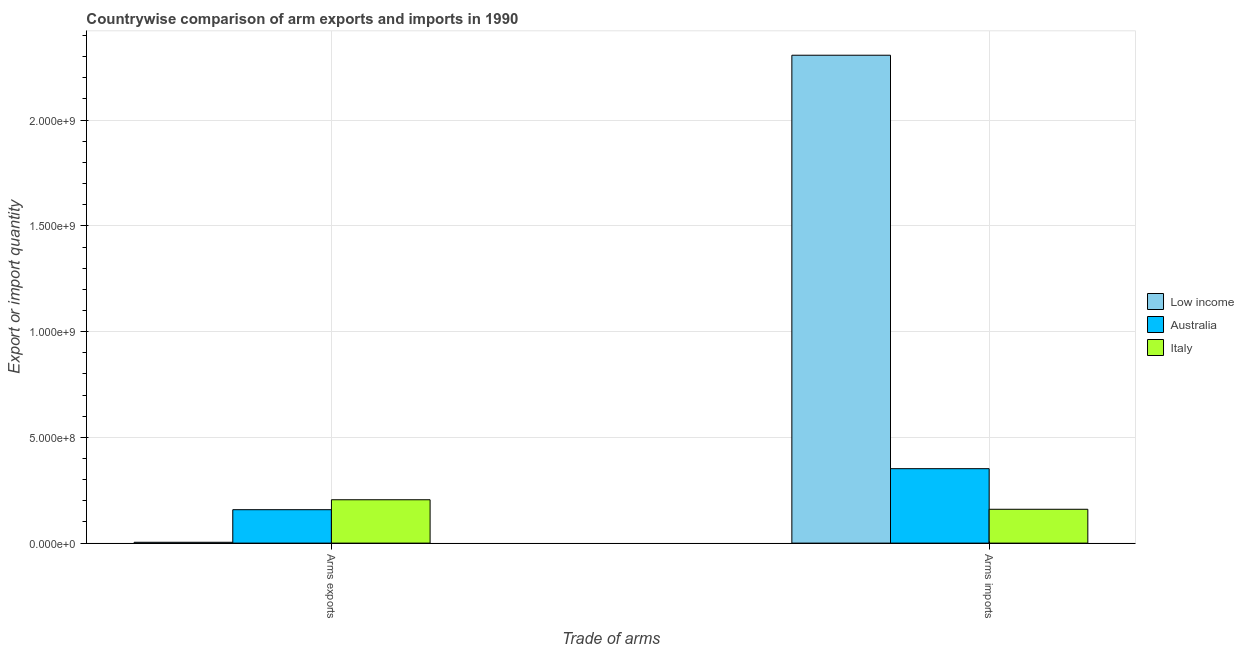How many different coloured bars are there?
Keep it short and to the point. 3. How many groups of bars are there?
Ensure brevity in your answer.  2. Are the number of bars per tick equal to the number of legend labels?
Make the answer very short. Yes. How many bars are there on the 2nd tick from the left?
Your answer should be compact. 3. What is the label of the 1st group of bars from the left?
Your answer should be very brief. Arms exports. What is the arms imports in Australia?
Give a very brief answer. 3.52e+08. Across all countries, what is the maximum arms imports?
Offer a very short reply. 2.31e+09. Across all countries, what is the minimum arms imports?
Offer a terse response. 1.60e+08. In which country was the arms exports maximum?
Provide a succinct answer. Italy. What is the total arms exports in the graph?
Provide a short and direct response. 3.67e+08. What is the difference between the arms exports in Australia and that in Low income?
Ensure brevity in your answer.  1.54e+08. What is the difference between the arms exports in Italy and the arms imports in Low income?
Ensure brevity in your answer.  -2.10e+09. What is the average arms exports per country?
Give a very brief answer. 1.22e+08. What is the difference between the arms imports and arms exports in Australia?
Ensure brevity in your answer.  1.94e+08. In how many countries, is the arms exports greater than 200000000 ?
Keep it short and to the point. 1. What is the ratio of the arms exports in Low income to that in Italy?
Your answer should be compact. 0.02. What does the 1st bar from the left in Arms imports represents?
Your answer should be very brief. Low income. What does the 1st bar from the right in Arms exports represents?
Give a very brief answer. Italy. Are the values on the major ticks of Y-axis written in scientific E-notation?
Provide a short and direct response. Yes. What is the title of the graph?
Offer a terse response. Countrywise comparison of arm exports and imports in 1990. Does "Czech Republic" appear as one of the legend labels in the graph?
Your response must be concise. No. What is the label or title of the X-axis?
Your answer should be very brief. Trade of arms. What is the label or title of the Y-axis?
Provide a short and direct response. Export or import quantity. What is the Export or import quantity of Low income in Arms exports?
Your response must be concise. 4.00e+06. What is the Export or import quantity of Australia in Arms exports?
Make the answer very short. 1.58e+08. What is the Export or import quantity of Italy in Arms exports?
Your answer should be very brief. 2.05e+08. What is the Export or import quantity in Low income in Arms imports?
Offer a terse response. 2.31e+09. What is the Export or import quantity in Australia in Arms imports?
Give a very brief answer. 3.52e+08. What is the Export or import quantity of Italy in Arms imports?
Provide a short and direct response. 1.60e+08. Across all Trade of arms, what is the maximum Export or import quantity of Low income?
Give a very brief answer. 2.31e+09. Across all Trade of arms, what is the maximum Export or import quantity of Australia?
Provide a short and direct response. 3.52e+08. Across all Trade of arms, what is the maximum Export or import quantity of Italy?
Your answer should be compact. 2.05e+08. Across all Trade of arms, what is the minimum Export or import quantity in Low income?
Your answer should be very brief. 4.00e+06. Across all Trade of arms, what is the minimum Export or import quantity in Australia?
Make the answer very short. 1.58e+08. Across all Trade of arms, what is the minimum Export or import quantity in Italy?
Your response must be concise. 1.60e+08. What is the total Export or import quantity of Low income in the graph?
Offer a terse response. 2.31e+09. What is the total Export or import quantity in Australia in the graph?
Ensure brevity in your answer.  5.10e+08. What is the total Export or import quantity of Italy in the graph?
Keep it short and to the point. 3.65e+08. What is the difference between the Export or import quantity in Low income in Arms exports and that in Arms imports?
Your response must be concise. -2.30e+09. What is the difference between the Export or import quantity of Australia in Arms exports and that in Arms imports?
Give a very brief answer. -1.94e+08. What is the difference between the Export or import quantity in Italy in Arms exports and that in Arms imports?
Make the answer very short. 4.50e+07. What is the difference between the Export or import quantity of Low income in Arms exports and the Export or import quantity of Australia in Arms imports?
Offer a terse response. -3.48e+08. What is the difference between the Export or import quantity of Low income in Arms exports and the Export or import quantity of Italy in Arms imports?
Your answer should be very brief. -1.56e+08. What is the difference between the Export or import quantity in Australia in Arms exports and the Export or import quantity in Italy in Arms imports?
Ensure brevity in your answer.  -2.00e+06. What is the average Export or import quantity of Low income per Trade of arms?
Provide a succinct answer. 1.16e+09. What is the average Export or import quantity of Australia per Trade of arms?
Give a very brief answer. 2.55e+08. What is the average Export or import quantity of Italy per Trade of arms?
Offer a terse response. 1.82e+08. What is the difference between the Export or import quantity of Low income and Export or import quantity of Australia in Arms exports?
Offer a terse response. -1.54e+08. What is the difference between the Export or import quantity of Low income and Export or import quantity of Italy in Arms exports?
Your response must be concise. -2.01e+08. What is the difference between the Export or import quantity in Australia and Export or import quantity in Italy in Arms exports?
Your answer should be very brief. -4.70e+07. What is the difference between the Export or import quantity of Low income and Export or import quantity of Australia in Arms imports?
Keep it short and to the point. 1.96e+09. What is the difference between the Export or import quantity of Low income and Export or import quantity of Italy in Arms imports?
Ensure brevity in your answer.  2.15e+09. What is the difference between the Export or import quantity in Australia and Export or import quantity in Italy in Arms imports?
Your answer should be very brief. 1.92e+08. What is the ratio of the Export or import quantity in Low income in Arms exports to that in Arms imports?
Give a very brief answer. 0. What is the ratio of the Export or import quantity of Australia in Arms exports to that in Arms imports?
Provide a short and direct response. 0.45. What is the ratio of the Export or import quantity in Italy in Arms exports to that in Arms imports?
Offer a very short reply. 1.28. What is the difference between the highest and the second highest Export or import quantity of Low income?
Provide a succinct answer. 2.30e+09. What is the difference between the highest and the second highest Export or import quantity in Australia?
Make the answer very short. 1.94e+08. What is the difference between the highest and the second highest Export or import quantity in Italy?
Your response must be concise. 4.50e+07. What is the difference between the highest and the lowest Export or import quantity in Low income?
Make the answer very short. 2.30e+09. What is the difference between the highest and the lowest Export or import quantity of Australia?
Your answer should be compact. 1.94e+08. What is the difference between the highest and the lowest Export or import quantity of Italy?
Offer a terse response. 4.50e+07. 